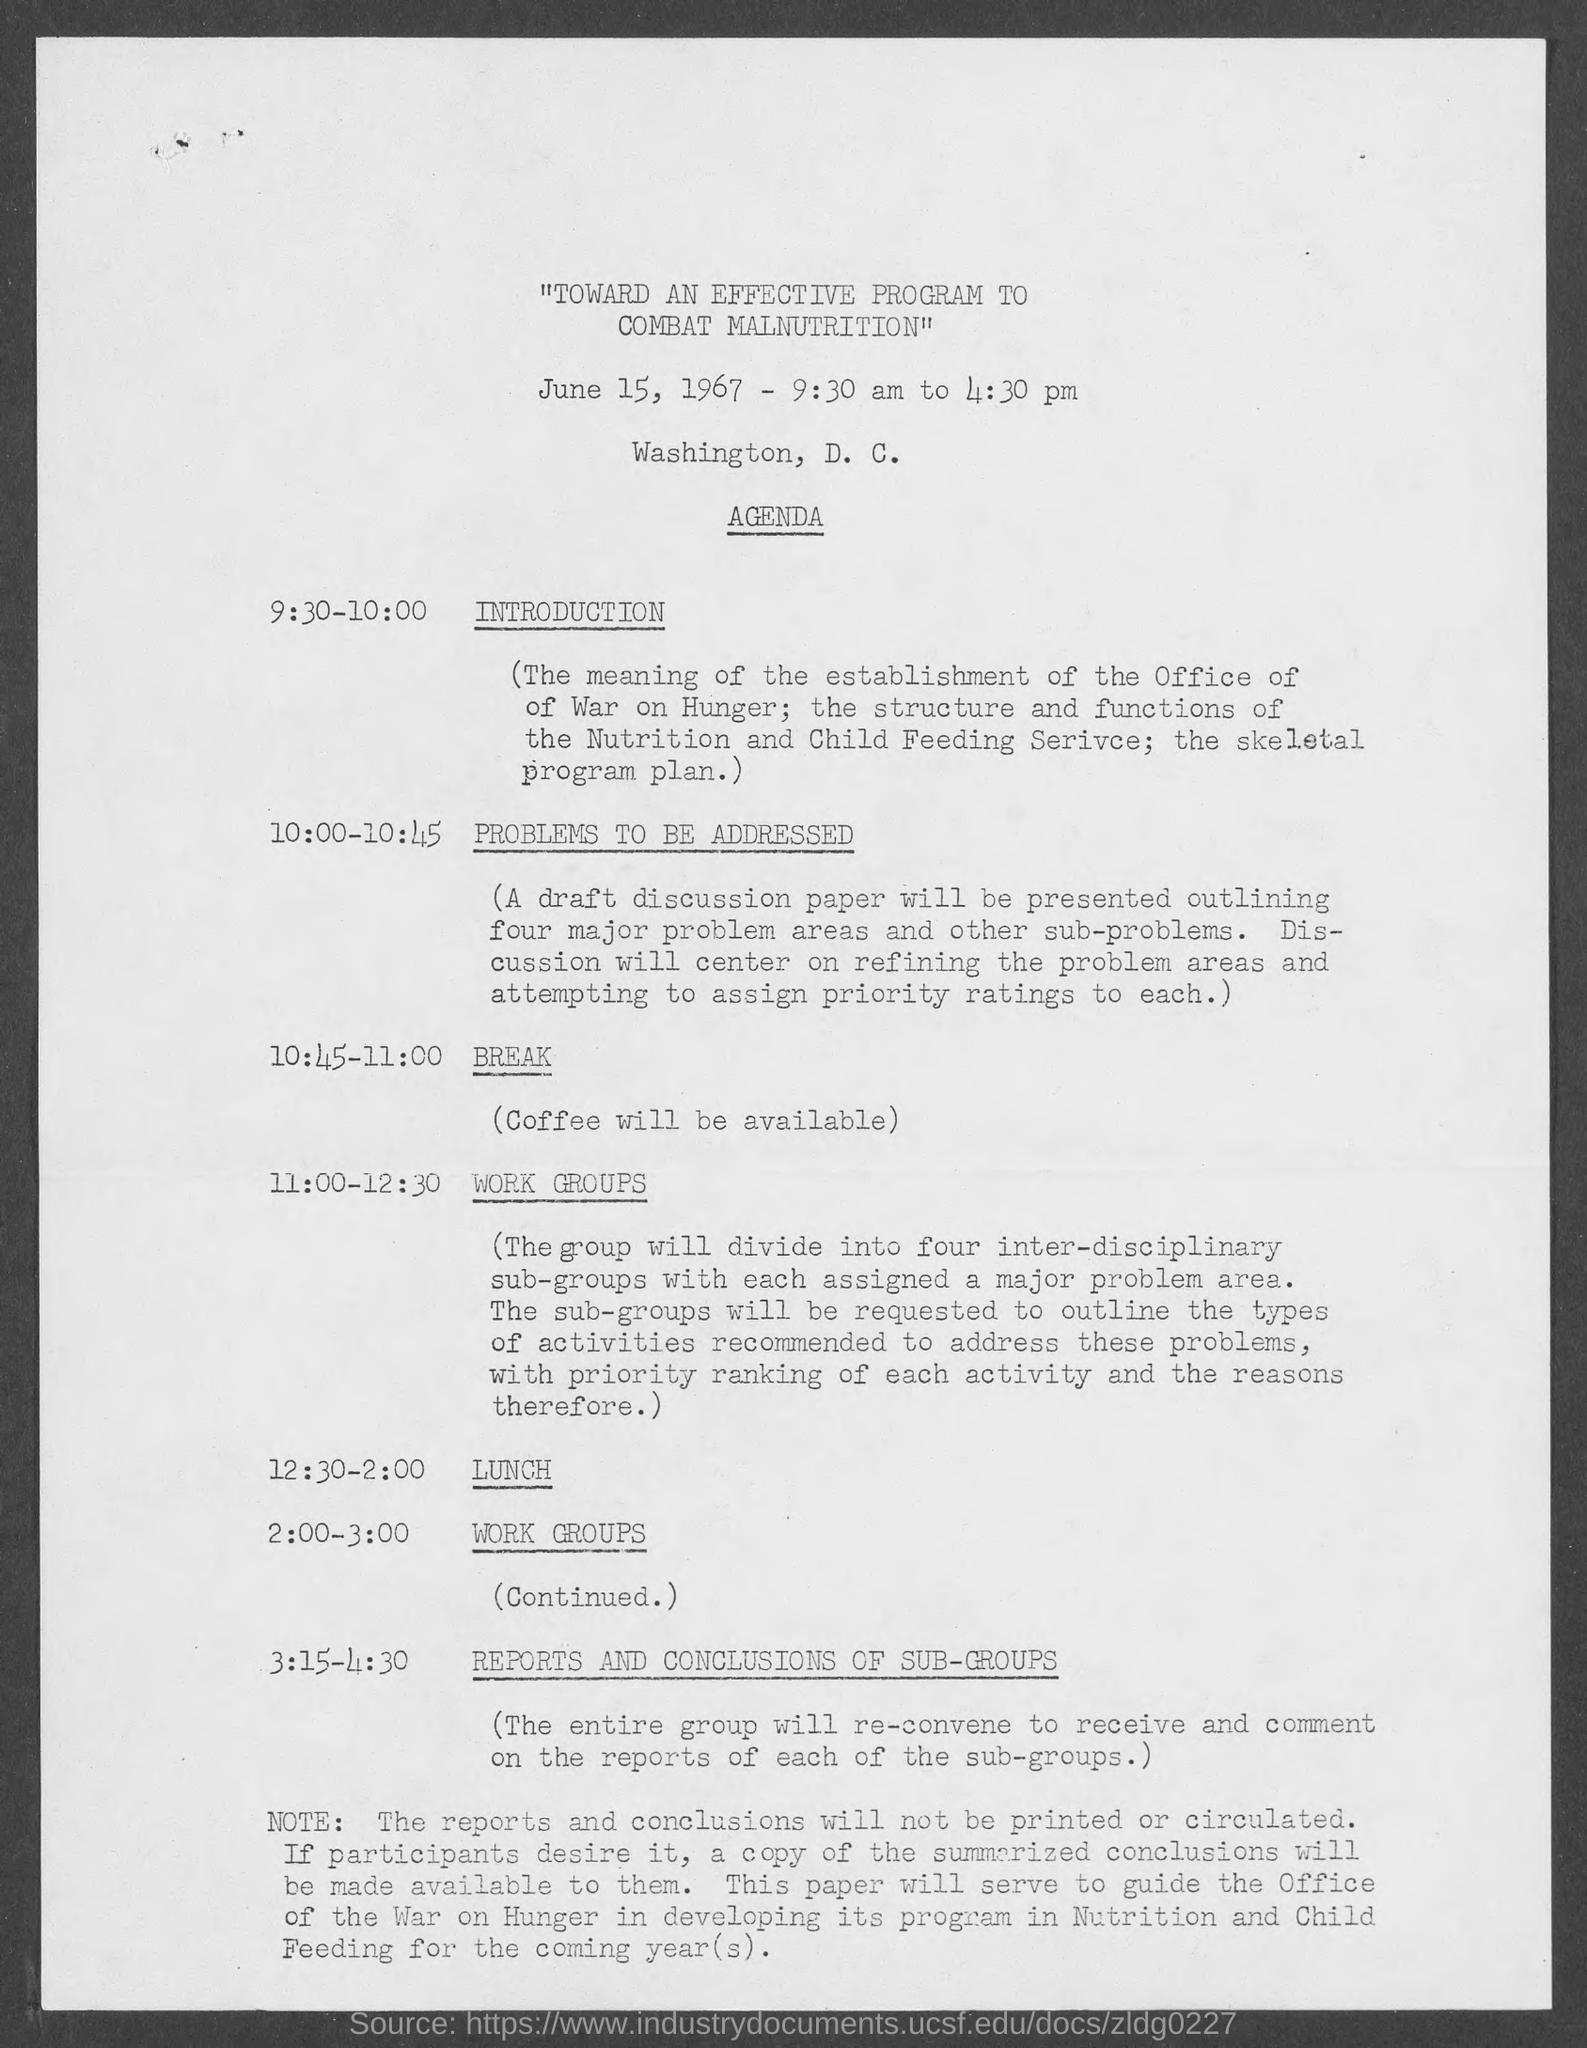On which date the program is scheduled ?
Make the answer very short. June 15, 1967. What is the scheduled time of the program ?
Provide a succinct answer. 9:30 am to 4:30 pm. What is the schedule at the time of 9:30-10:00 ?
Provide a succinct answer. Introduction. During what time is the item  "problems to be addressed"?
Give a very brief answer. 10:00 - 10:45. What is the schedule at the time of 10:45-11:00 ?
Provide a succinct answer. Break. What will be available during the break ?
Your response must be concise. Coffee. What is the given schedule at the time of 11:00 - 12:30 ?
Offer a terse response. Work groups. What is the schedule at the time of 12:30-2:00 ?
Keep it short and to the point. Lunch. What is  scheduled during of 2:00 - 3:00 ?
Your response must be concise. Work groups. What is  scheduled during  3:15 - 4:30 ?
Give a very brief answer. Reports and conclusions of sub-groups. 